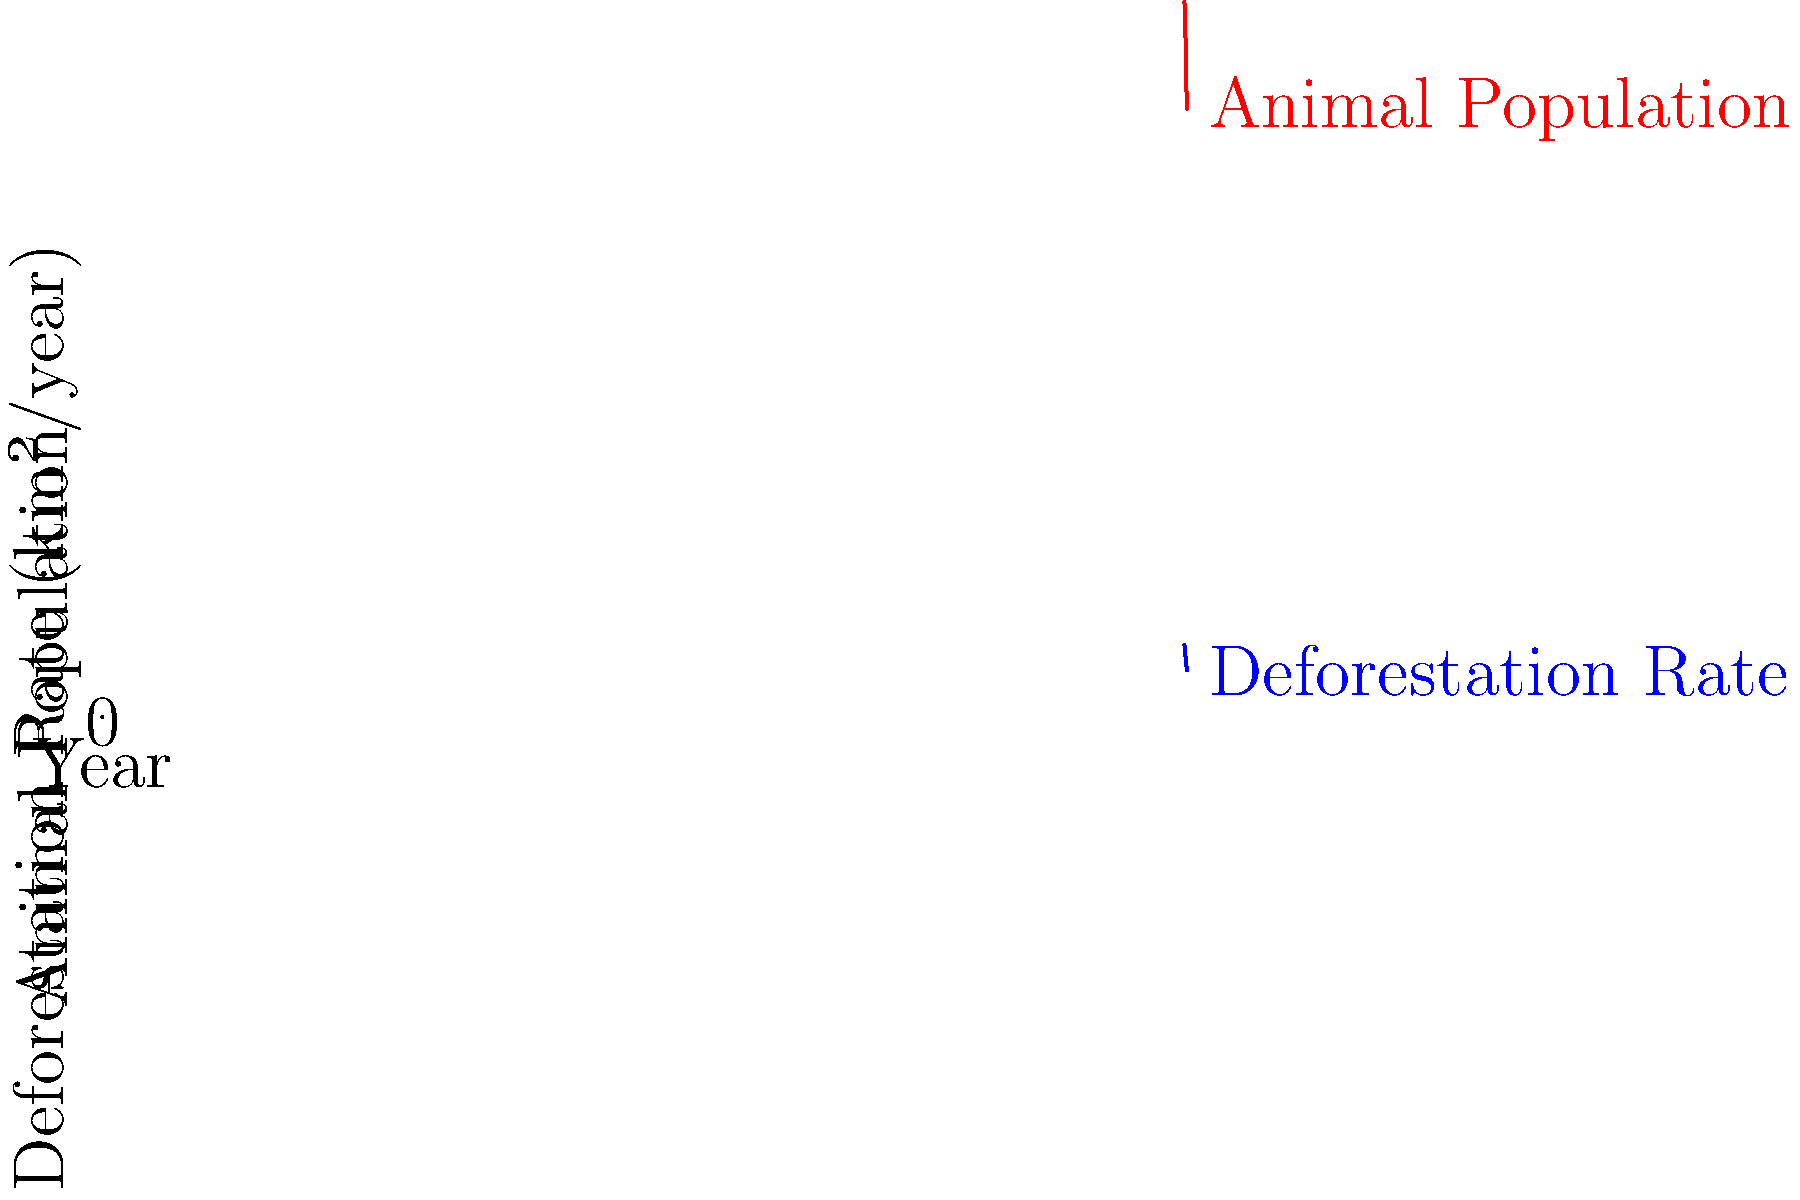Based on the line graph showing deforestation rates and animal population changes from 2010 to 2015, calculate the Pearson correlation coefficient ($r$) between these two variables. What does this value indicate about the relationship between deforestation and animal population? To calculate the Pearson correlation coefficient ($r$) and interpret its meaning, we'll follow these steps:

1. Calculate the means of both variables:
   $\bar{x}$ (Deforestation) = 81.67
   $\bar{y}$ (Animal Population) = 925

2. Calculate the deviations from the mean for each variable.

3. Multiply the deviations for each pair of points.

4. Sum the products of deviations: $\sum(x_i - \bar{x})(y_i - \bar{y})$ = 3195.83

5. Calculate the sum of squared deviations for each variable:
   $\sum(x_i - \bar{x})^2$ = 1147.22
   $\sum(y_i - \bar{y})^2$ = 31250

6. Apply the formula for Pearson's $r$:
   $r = \frac{\sum(x_i - \bar{x})(y_i - \bar{y})}{\sqrt{\sum(x_i - \bar{x})^2 \sum(y_i - \bar{y})^2}}$

   $r = \frac{3195.83}{\sqrt{1147.22 \times 31250}} \approx 0.9989$

7. Interpret the result:
   - The value of $r$ is very close to 1, indicating a strong positive correlation.
   - This suggests that as deforestation rates decrease, animal population sizes also decrease.
   - The relationship is almost perfectly linear, implying a very strong connection between the two variables.
Answer: $r \approx 0.9989$; Strong positive correlation 